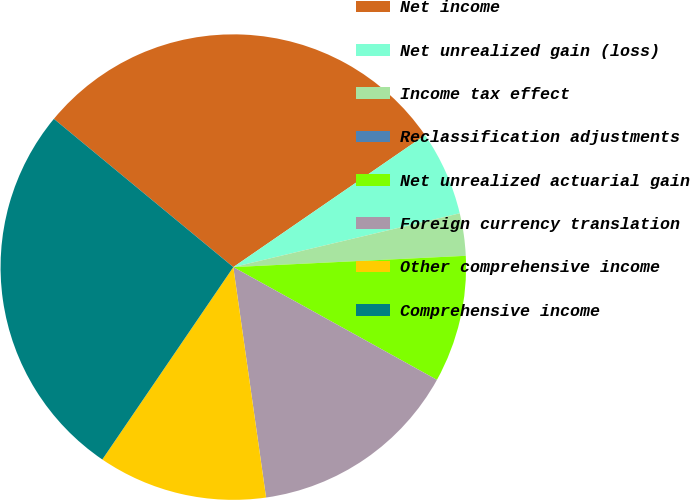Convert chart to OTSL. <chart><loc_0><loc_0><loc_500><loc_500><pie_chart><fcel>Net income<fcel>Net unrealized gain (loss)<fcel>Income tax effect<fcel>Reclassification adjustments<fcel>Net unrealized actuarial gain<fcel>Foreign currency translation<fcel>Other comprehensive income<fcel>Comprehensive income<nl><fcel>29.41%<fcel>5.88%<fcel>2.94%<fcel>0.0%<fcel>8.82%<fcel>14.7%<fcel>11.76%<fcel>26.47%<nl></chart> 